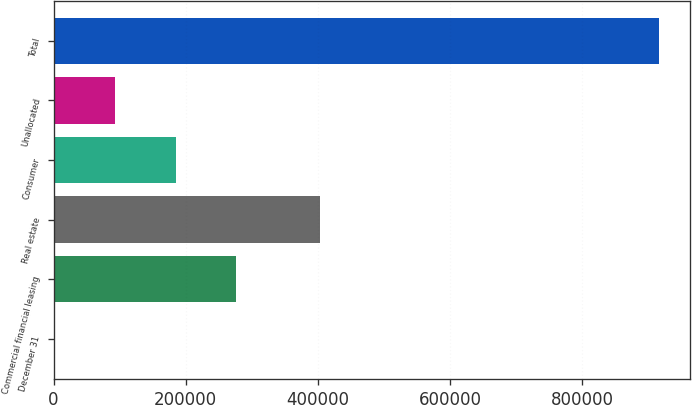Convert chart to OTSL. <chart><loc_0><loc_0><loc_500><loc_500><bar_chart><fcel>December 31<fcel>Commercial financial leasing<fcel>Real estate<fcel>Consumer<fcel>Unallocated<fcel>Total<nl><fcel>2013<fcel>276412<fcel>403634<fcel>184946<fcel>93479.3<fcel>916676<nl></chart> 